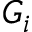<formula> <loc_0><loc_0><loc_500><loc_500>G _ { i }</formula> 